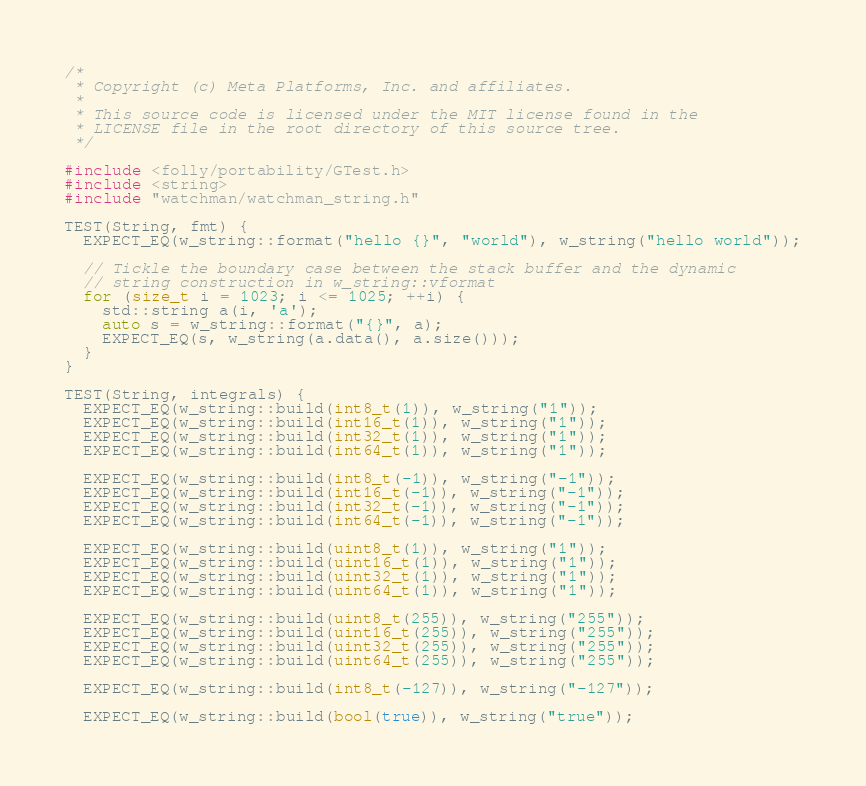<code> <loc_0><loc_0><loc_500><loc_500><_C++_>/*
 * Copyright (c) Meta Platforms, Inc. and affiliates.
 *
 * This source code is licensed under the MIT license found in the
 * LICENSE file in the root directory of this source tree.
 */

#include <folly/portability/GTest.h>
#include <string>
#include "watchman/watchman_string.h"

TEST(String, fmt) {
  EXPECT_EQ(w_string::format("hello {}", "world"), w_string("hello world"));

  // Tickle the boundary case between the stack buffer and the dynamic
  // string construction in w_string::vformat
  for (size_t i = 1023; i <= 1025; ++i) {
    std::string a(i, 'a');
    auto s = w_string::format("{}", a);
    EXPECT_EQ(s, w_string(a.data(), a.size()));
  }
}

TEST(String, integrals) {
  EXPECT_EQ(w_string::build(int8_t(1)), w_string("1"));
  EXPECT_EQ(w_string::build(int16_t(1)), w_string("1"));
  EXPECT_EQ(w_string::build(int32_t(1)), w_string("1"));
  EXPECT_EQ(w_string::build(int64_t(1)), w_string("1"));

  EXPECT_EQ(w_string::build(int8_t(-1)), w_string("-1"));
  EXPECT_EQ(w_string::build(int16_t(-1)), w_string("-1"));
  EXPECT_EQ(w_string::build(int32_t(-1)), w_string("-1"));
  EXPECT_EQ(w_string::build(int64_t(-1)), w_string("-1"));

  EXPECT_EQ(w_string::build(uint8_t(1)), w_string("1"));
  EXPECT_EQ(w_string::build(uint16_t(1)), w_string("1"));
  EXPECT_EQ(w_string::build(uint32_t(1)), w_string("1"));
  EXPECT_EQ(w_string::build(uint64_t(1)), w_string("1"));

  EXPECT_EQ(w_string::build(uint8_t(255)), w_string("255"));
  EXPECT_EQ(w_string::build(uint16_t(255)), w_string("255"));
  EXPECT_EQ(w_string::build(uint32_t(255)), w_string("255"));
  EXPECT_EQ(w_string::build(uint64_t(255)), w_string("255"));

  EXPECT_EQ(w_string::build(int8_t(-127)), w_string("-127"));

  EXPECT_EQ(w_string::build(bool(true)), w_string("true"));</code> 